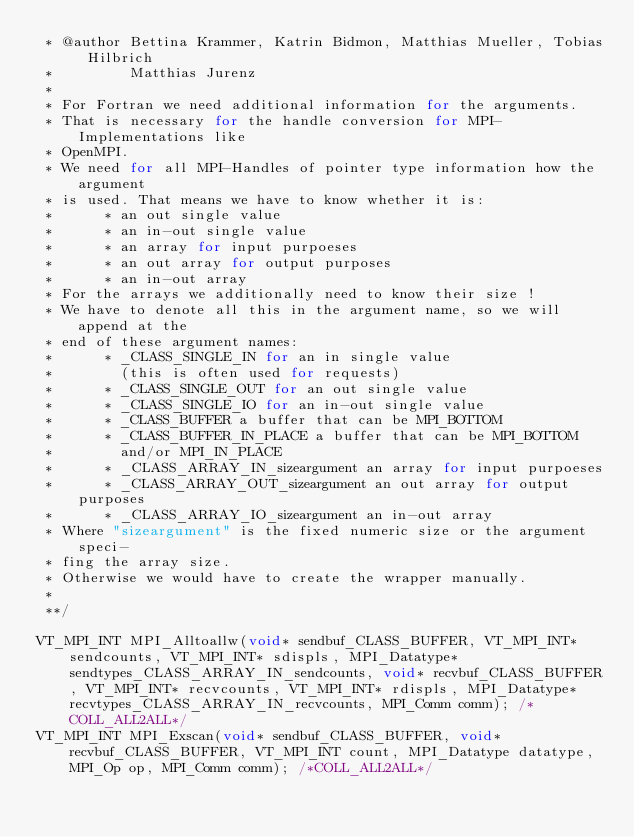<code> <loc_0><loc_0><loc_500><loc_500><_C_> * @author Bettina Krammer, Katrin Bidmon, Matthias Mueller, Tobias Hilbrich
 *         Matthias Jurenz
 *
 * For Fortran we need additional information for the arguments.
 * That is necessary for the handle conversion for MPI-Implementations like
 * OpenMPI.
 * We need for all MPI-Handles of pointer type information how the argument
 * is used. That means we have to know whether it is:
 *      * an out single value
 *      * an in-out single value
 *      * an array for input purpoeses
 *      * an out array for output purposes
 *      * an in-out array
 * For the arrays we additionally need to know their size !
 * We have to denote all this in the argument name, so we will append at the 
 * end of these argument names:
 *      * _CLASS_SINGLE_IN for an in single value
 *        (this is often used for requests)
 *      * _CLASS_SINGLE_OUT for an out single value
 *      * _CLASS_SINGLE_IO for an in-out single value
 *      * _CLASS_BUFFER a buffer that can be MPI_BOTTOM
 *      * _CLASS_BUFFER_IN_PLACE a buffer that can be MPI_BOTTOM
 *        and/or MPI_IN_PLACE
 *      * _CLASS_ARRAY_IN_sizeargument an array for input purpoeses
 *      * _CLASS_ARRAY_OUT_sizeargument an out array for output purposes
 *      * _CLASS_ARRAY_IO_sizeargument an in-out array
 * Where "sizeargument" is the fixed numeric size or the argument speci-
 * fing the array size.
 * Otherwise we would have to create the wrapper manually.
 *
 **/

VT_MPI_INT MPI_Alltoallw(void* sendbuf_CLASS_BUFFER, VT_MPI_INT* sendcounts, VT_MPI_INT* sdispls, MPI_Datatype* sendtypes_CLASS_ARRAY_IN_sendcounts, void* recvbuf_CLASS_BUFFER, VT_MPI_INT* recvcounts, VT_MPI_INT* rdispls, MPI_Datatype* recvtypes_CLASS_ARRAY_IN_recvcounts, MPI_Comm comm); /*COLL_ALL2ALL*/
VT_MPI_INT MPI_Exscan(void* sendbuf_CLASS_BUFFER, void* recvbuf_CLASS_BUFFER, VT_MPI_INT count, MPI_Datatype datatype, MPI_Op op, MPI_Comm comm); /*COLL_ALL2ALL*/
</code> 